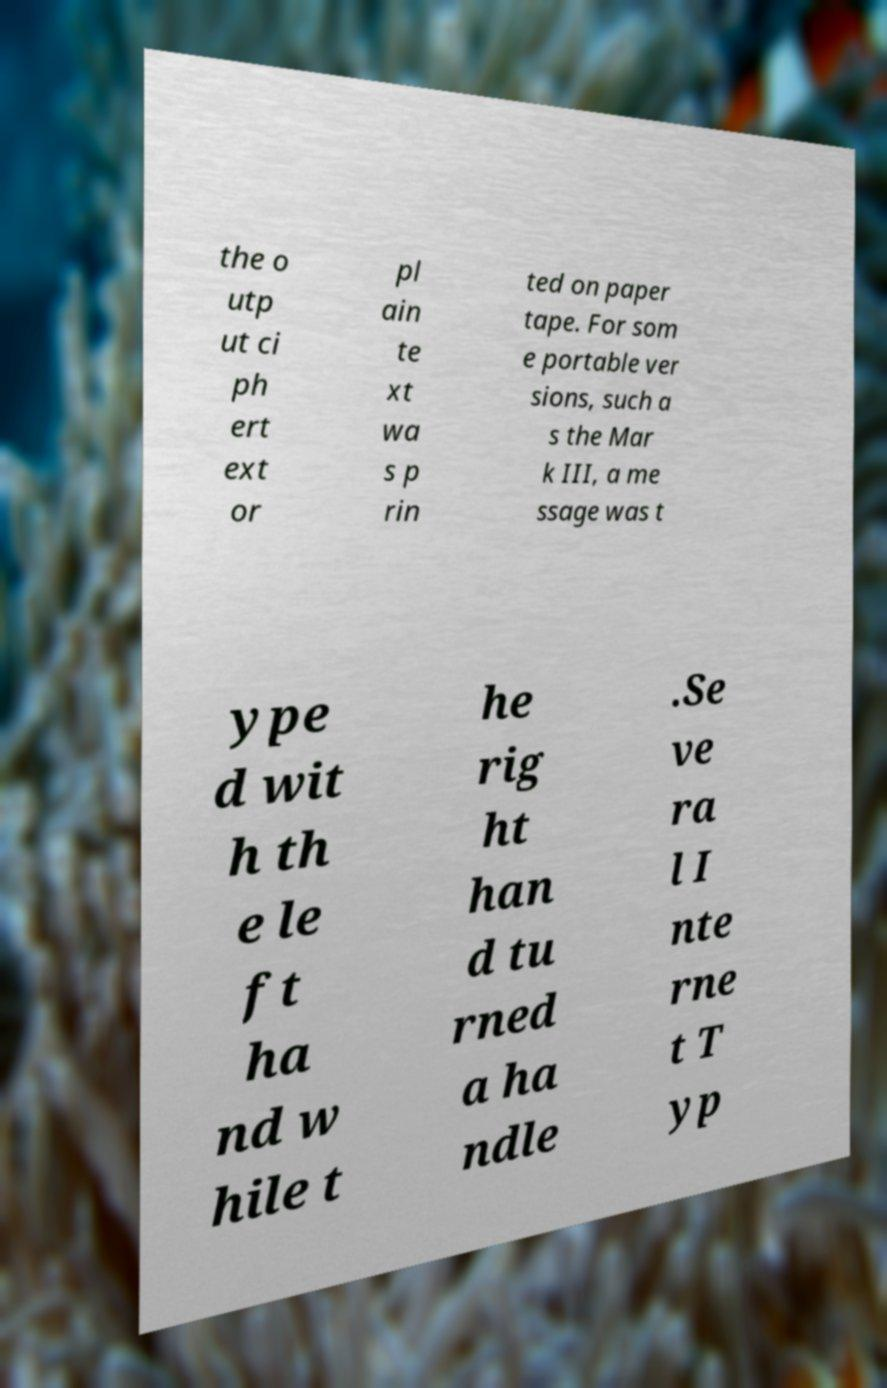Can you accurately transcribe the text from the provided image for me? the o utp ut ci ph ert ext or pl ain te xt wa s p rin ted on paper tape. For som e portable ver sions, such a s the Mar k III, a me ssage was t ype d wit h th e le ft ha nd w hile t he rig ht han d tu rned a ha ndle .Se ve ra l I nte rne t T yp 